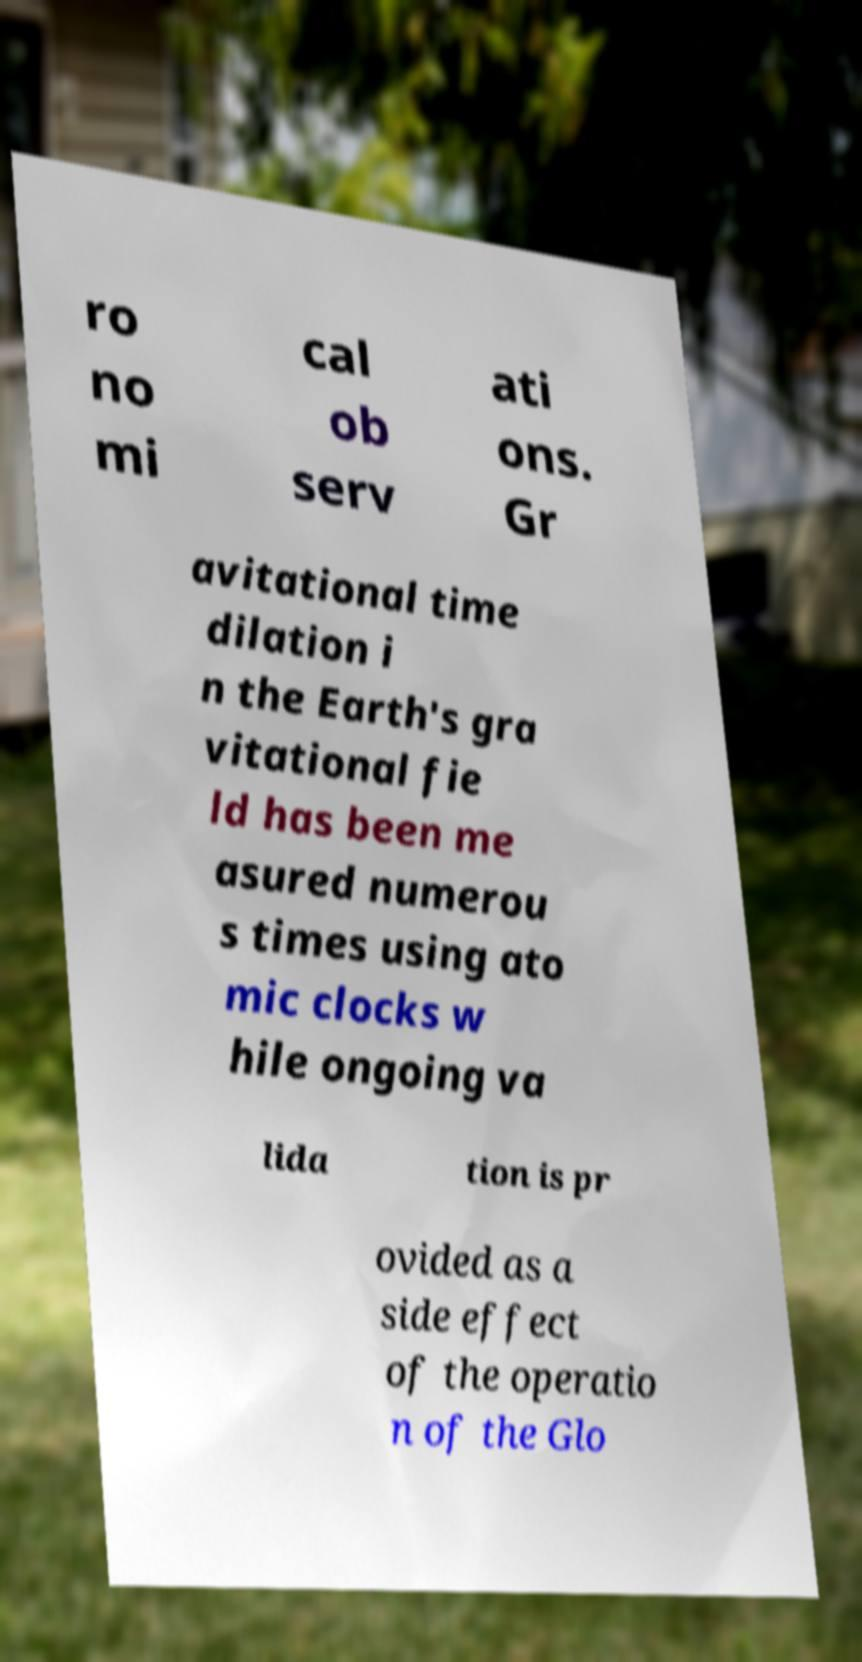What messages or text are displayed in this image? I need them in a readable, typed format. ro no mi cal ob serv ati ons. Gr avitational time dilation i n the Earth's gra vitational fie ld has been me asured numerou s times using ato mic clocks w hile ongoing va lida tion is pr ovided as a side effect of the operatio n of the Glo 